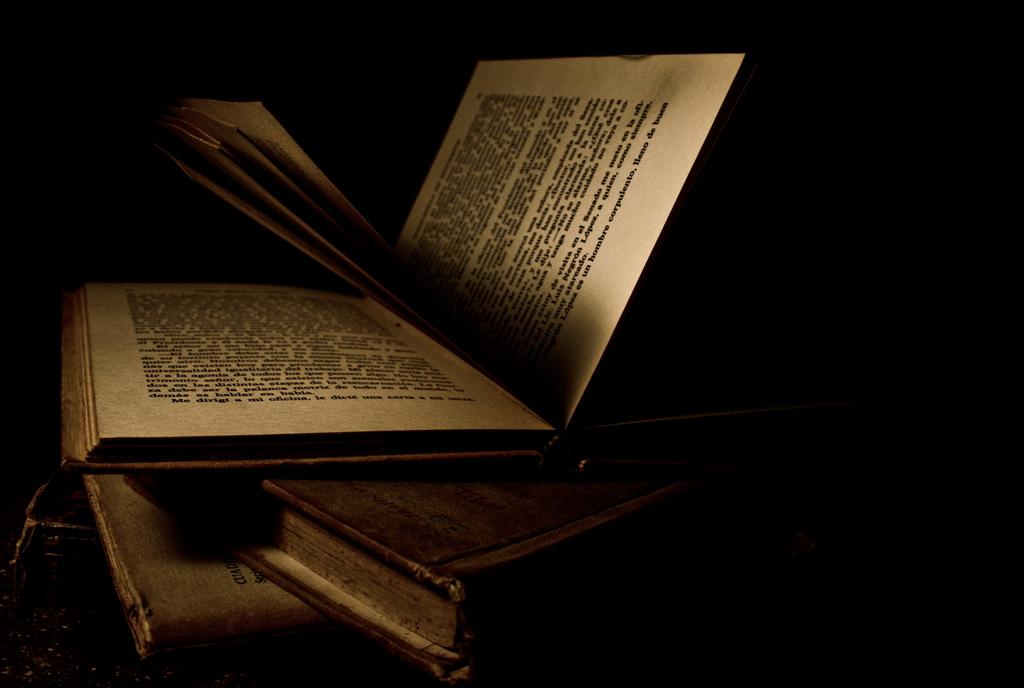<image>
Write a terse but informative summary of the picture. An old book is opened to a page with "me" on the bottom line of the left page. 